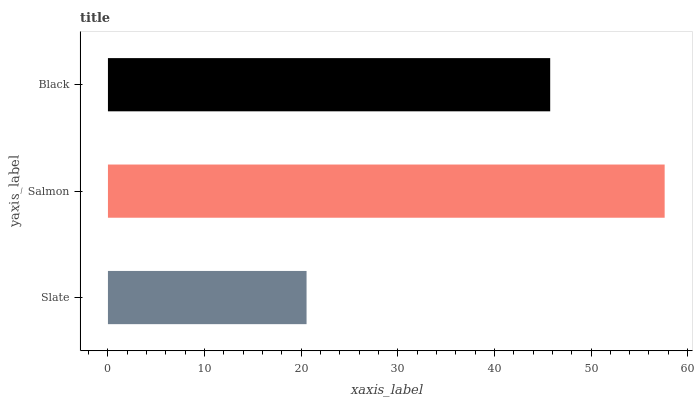Is Slate the minimum?
Answer yes or no. Yes. Is Salmon the maximum?
Answer yes or no. Yes. Is Black the minimum?
Answer yes or no. No. Is Black the maximum?
Answer yes or no. No. Is Salmon greater than Black?
Answer yes or no. Yes. Is Black less than Salmon?
Answer yes or no. Yes. Is Black greater than Salmon?
Answer yes or no. No. Is Salmon less than Black?
Answer yes or no. No. Is Black the high median?
Answer yes or no. Yes. Is Black the low median?
Answer yes or no. Yes. Is Slate the high median?
Answer yes or no. No. Is Salmon the low median?
Answer yes or no. No. 